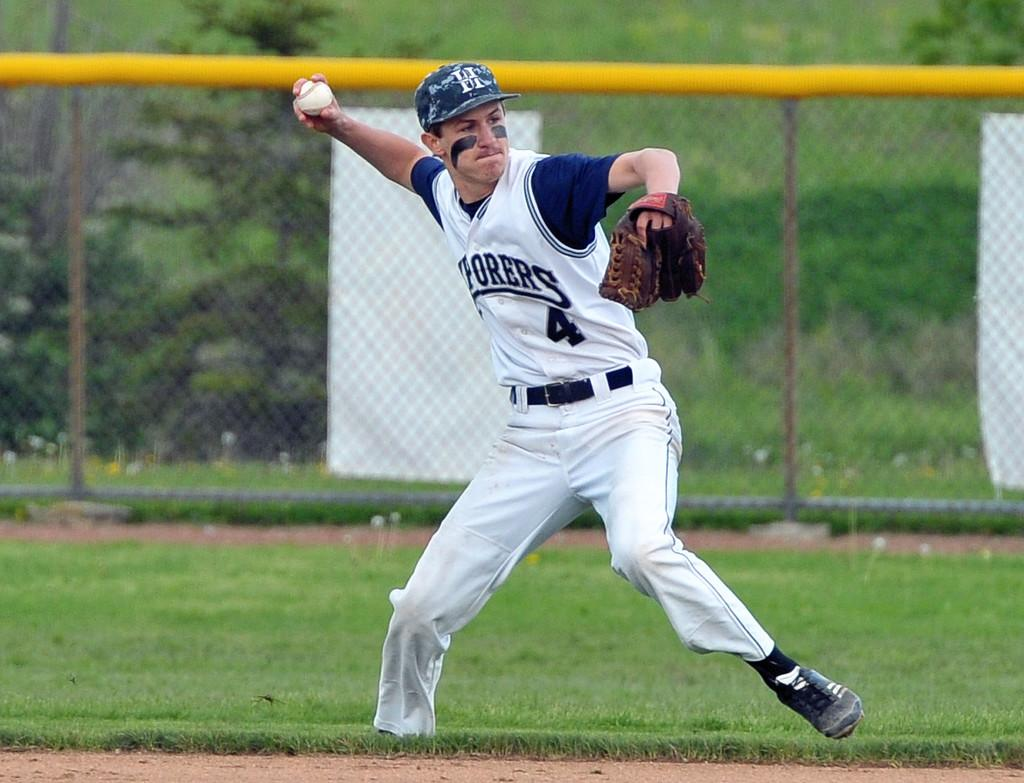<image>
Describe the image concisely. Pitcher number 4 getting ready to throw the ball 